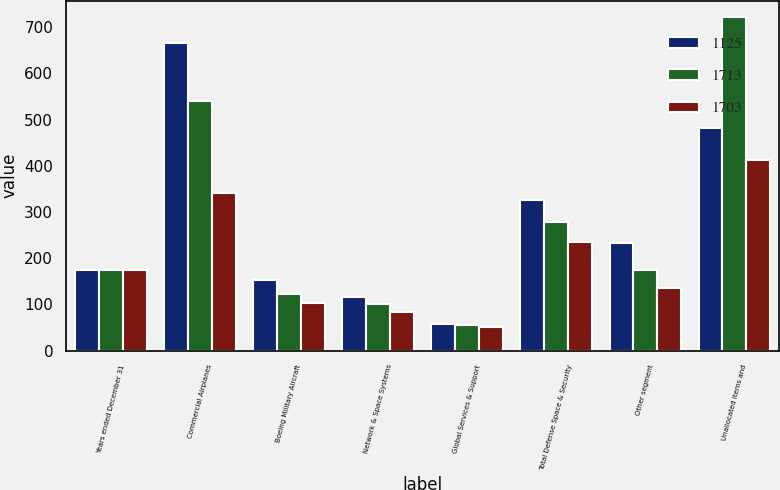Convert chart to OTSL. <chart><loc_0><loc_0><loc_500><loc_500><stacked_bar_chart><ecel><fcel>Years ended December 31<fcel>Commercial Airplanes<fcel>Boeing Military Aircraft<fcel>Network & Space Systems<fcel>Global Services & Support<fcel>Total Defense Space & Security<fcel>Other segment<fcel>Unallocated items and<nl><fcel>1125<fcel>174<fcel>665<fcel>153<fcel>115<fcel>57<fcel>325<fcel>232<fcel>481<nl><fcel>1713<fcel>174<fcel>540<fcel>122<fcel>101<fcel>55<fcel>278<fcel>174<fcel>721<nl><fcel>1703<fcel>174<fcel>341<fcel>102<fcel>83<fcel>51<fcel>236<fcel>136<fcel>412<nl></chart> 